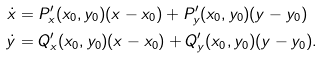Convert formula to latex. <formula><loc_0><loc_0><loc_500><loc_500>\dot { x } & = P ^ { \prime } _ { x } ( x _ { 0 } , y _ { 0 } ) ( x - x _ { 0 } ) + P ^ { \prime } _ { y } ( x _ { 0 } , y _ { 0 } ) ( y - y _ { 0 } ) \\ \dot { y } & = Q ^ { \prime } _ { x } ( x _ { 0 } , y _ { 0 } ) ( x - x _ { 0 } ) + Q ^ { \prime } _ { y } ( x _ { 0 } , y _ { 0 } ) ( y - y _ { 0 } ) .</formula> 